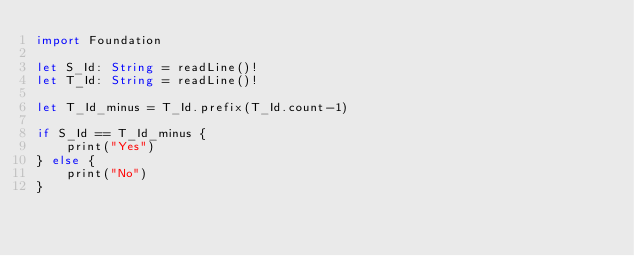<code> <loc_0><loc_0><loc_500><loc_500><_Swift_>import Foundation

let S_Id: String = readLine()!
let T_Id: String = readLine()!

let T_Id_minus = T_Id.prefix(T_Id.count-1)

if S_Id == T_Id_minus {
    print("Yes")
} else {
    print("No")
}
</code> 